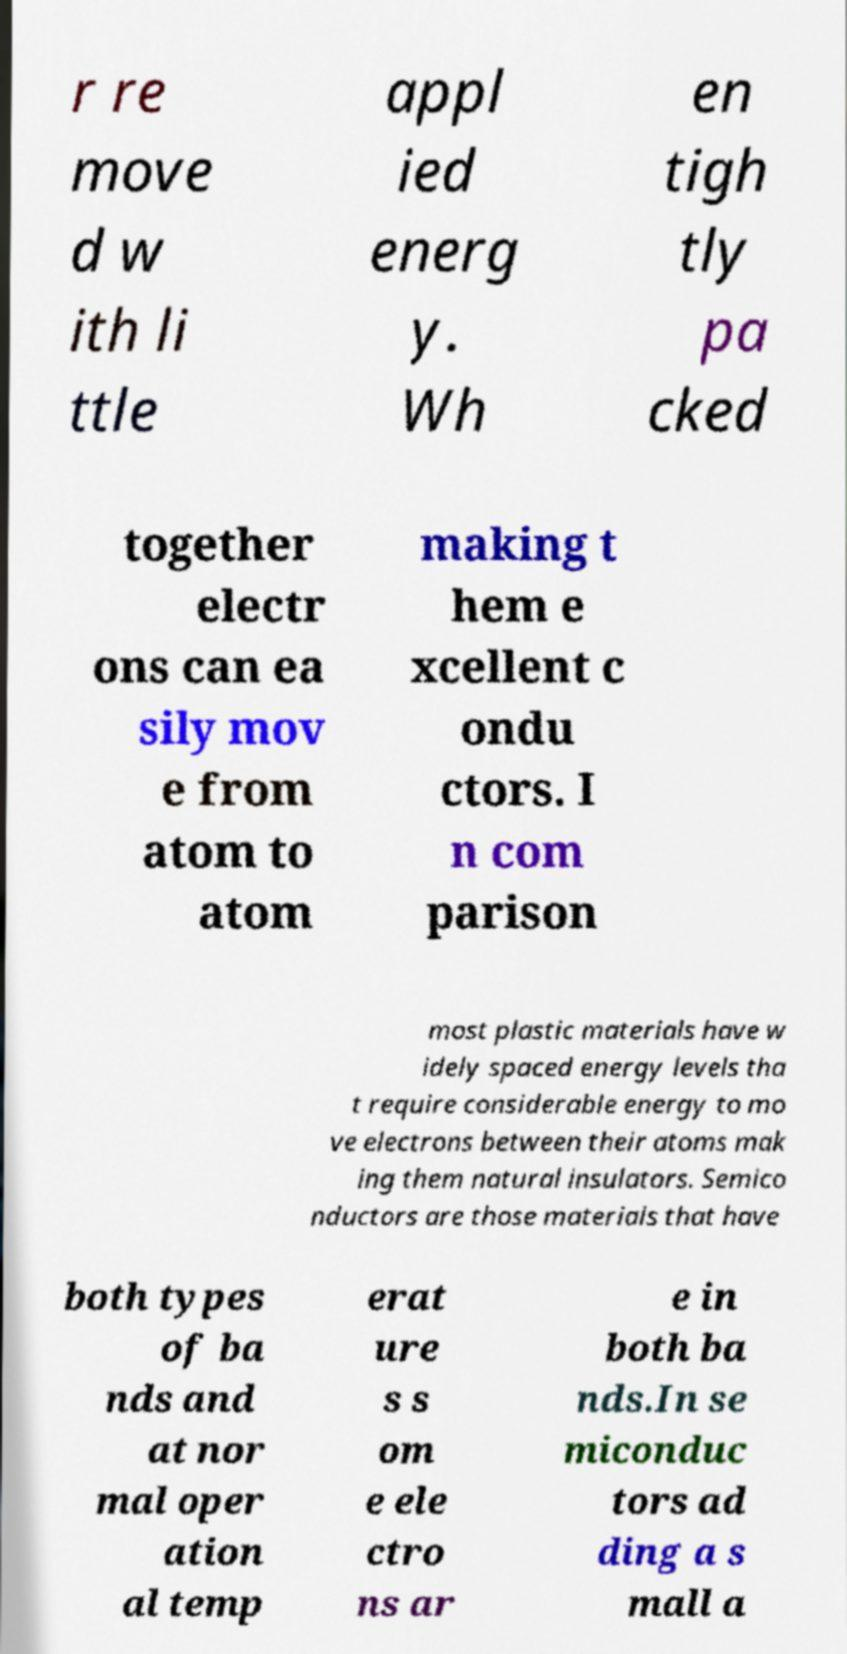For documentation purposes, I need the text within this image transcribed. Could you provide that? r re move d w ith li ttle appl ied energ y. Wh en tigh tly pa cked together electr ons can ea sily mov e from atom to atom making t hem e xcellent c ondu ctors. I n com parison most plastic materials have w idely spaced energy levels tha t require considerable energy to mo ve electrons between their atoms mak ing them natural insulators. Semico nductors are those materials that have both types of ba nds and at nor mal oper ation al temp erat ure s s om e ele ctro ns ar e in both ba nds.In se miconduc tors ad ding a s mall a 